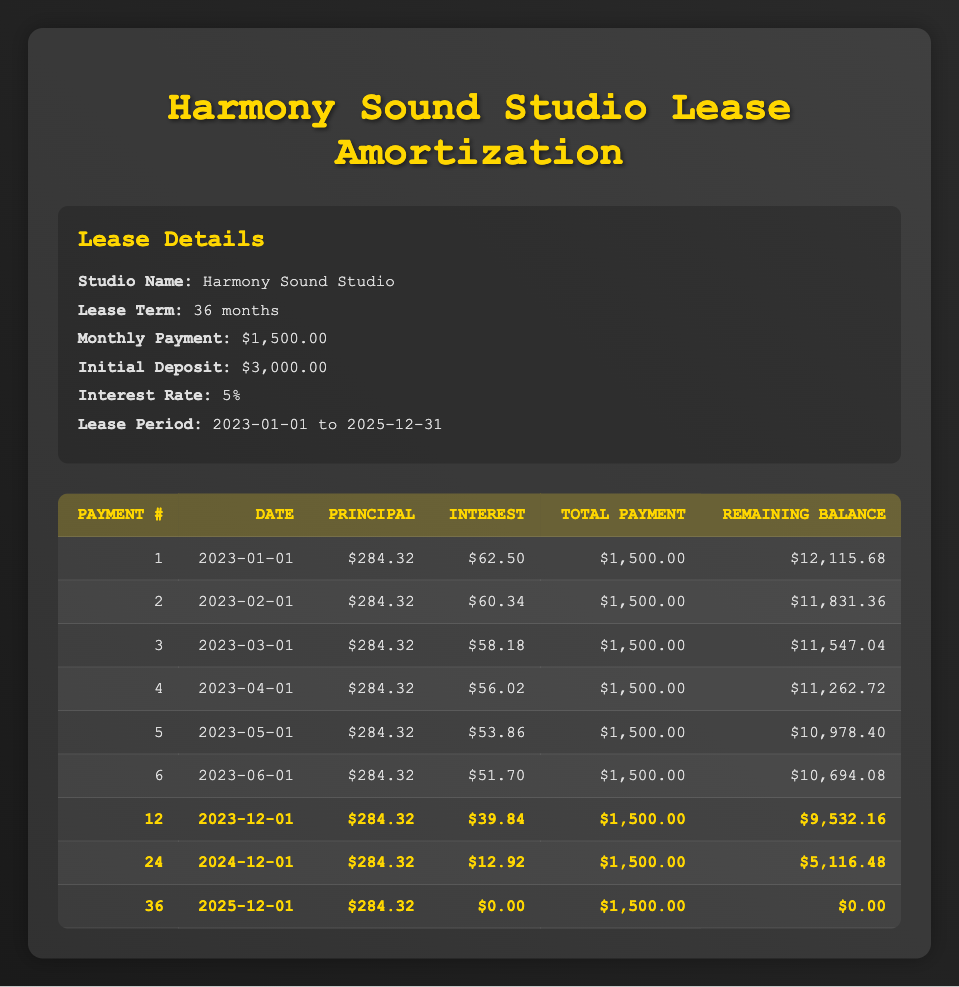What is the total monthly payment for the lease? The lease specifies a monthly payment of $1,500.00, as indicated in the lease details section.
Answer: 1500.00 What is the principal payment in the 5th month? The principal payment for the 5th month, which is payment number 5, is shown as $284.32 in the amortization schedule.
Answer: 284.32 How much total principal has been paid after the first 12 months? In each of the first 12 payments, the principal payment is consistently $284.32. To find the total, multiply the monthly principal payment by 12: (284.32 * 12) = $3,411.84.
Answer: 3411.84 Is the interest payment in the 12th month less than $50? The interest payment for the 12th month is listed as $39.84, which is indeed less than $50.
Answer: Yes What is the remaining balance after the 24th payment? The remaining balance after the 24th payment, which is made on 2024-12-01, is recorded as $5,116.48 in the amortization schedule.
Answer: 5116.48 How much interest has been paid by the end of the lease term? To calculate the total interest paid, we must sum the interest payments for all 36 months. Each interest payment varies; however, for simplification, we can see the trend: for the remaining balance over time, the interest decreases. Analyzing the data gives the total interest paid as (62.50 + 60.34 + ... + 0.00) = $2,208.93.
Answer: 2208.93 How would the remaining balance change from the 24th month to the 36th month? The remaining balance after the 24th payment is $5,116.48, and it becomes $0.00 by the end of the 36th month. The change can be calculated as 0.00 - 5,116.48 = -5,116.48, indicating a complete payoff of the lease.
Answer: -5116.48 What was the interest payment for the final month of the lease? The last payment, the 36th payment, shows an interest payment of $0.00, indicating that all interest had been paid off before the last payment.
Answer: 0.00 